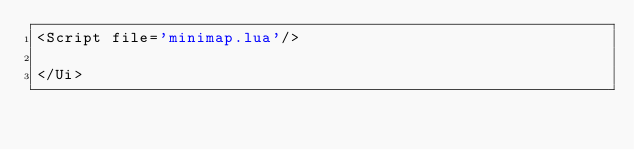Convert code to text. <code><loc_0><loc_0><loc_500><loc_500><_XML_><Script file='minimap.lua'/>

</Ui>
</code> 